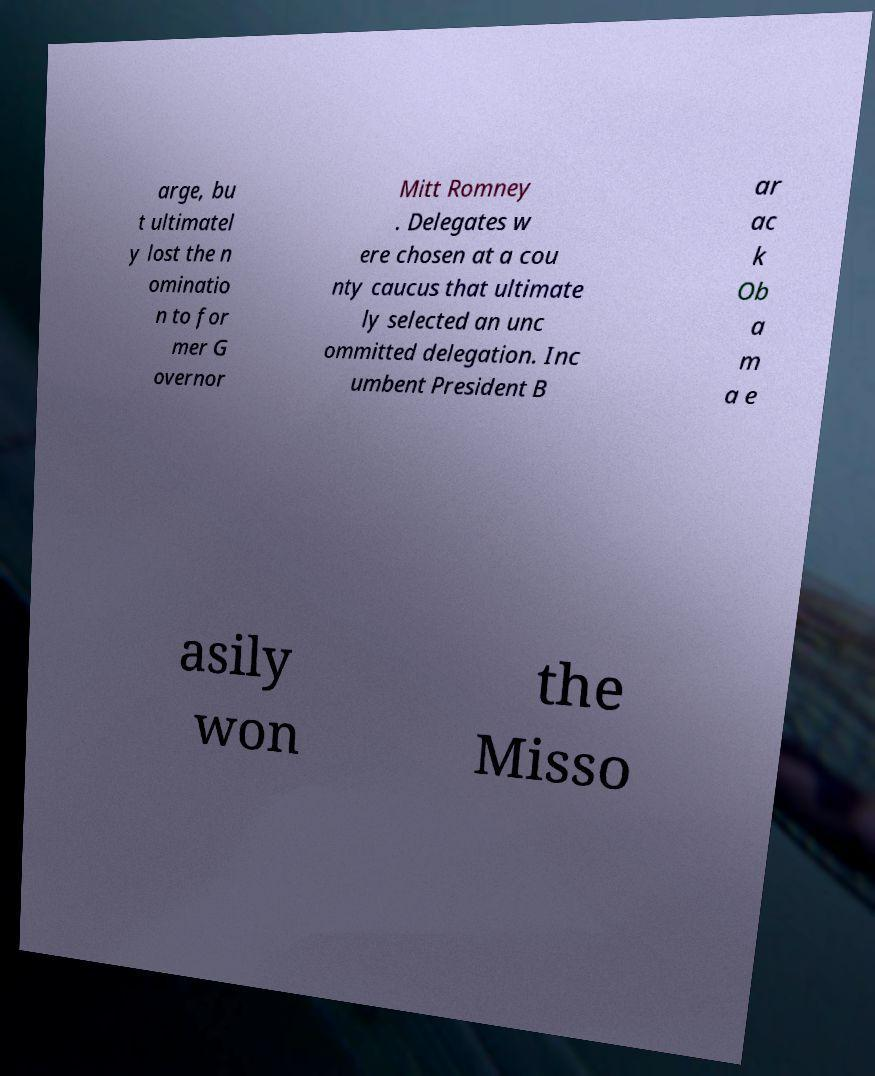What messages or text are displayed in this image? I need them in a readable, typed format. arge, bu t ultimatel y lost the n ominatio n to for mer G overnor Mitt Romney . Delegates w ere chosen at a cou nty caucus that ultimate ly selected an unc ommitted delegation. Inc umbent President B ar ac k Ob a m a e asily won the Misso 